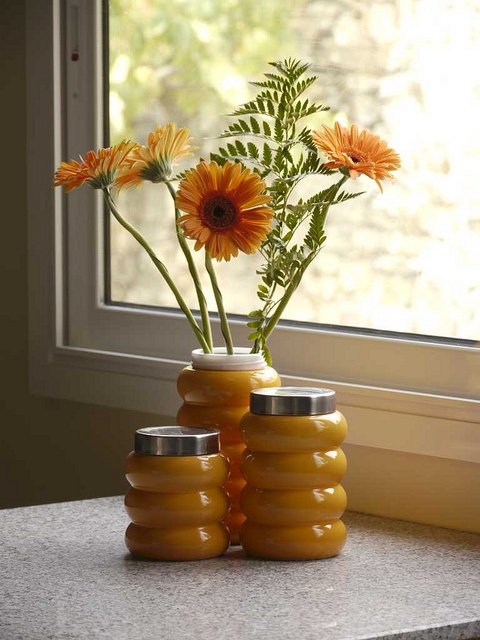Describe the objects in this image and their specific colors. I can see potted plant in black, olive, beige, and maroon tones, vase in black, maroon, and olive tones, vase in black, maroon, and olive tones, and vase in black, maroon, brown, and ivory tones in this image. 